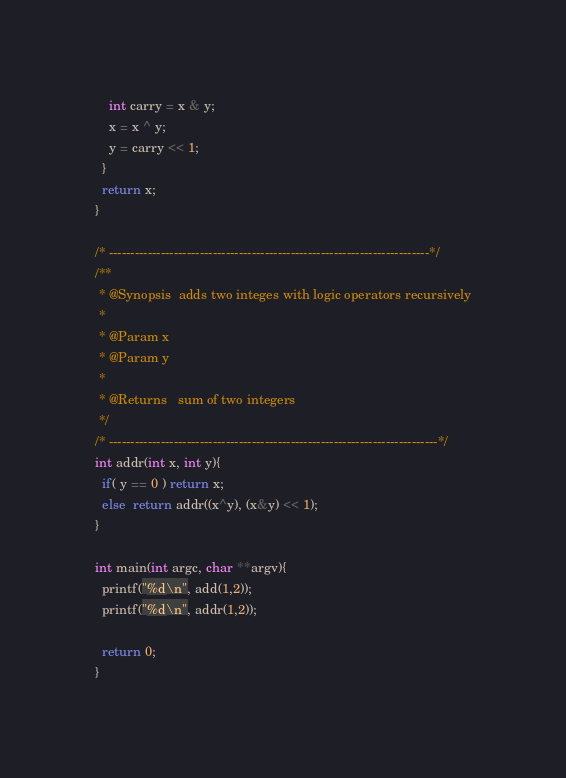<code> <loc_0><loc_0><loc_500><loc_500><_C_>    int carry = x & y;
    x = x ^ y;
    y = carry << 1;
  }
  return x;
}

/* --------------------------------------------------------------------------*/
/**
 * @Synopsis  adds two integes with logic operators recursively
 *
 * @Param x
 * @Param y
 *
 * @Returns   sum of two integers
 */
/* ----------------------------------------------------------------------------*/
int addr(int x, int y){
  if( y == 0 ) return x;
  else  return addr((x^y), (x&y) << 1);
}

int main(int argc, char **argv){
  printf("%d\n", add(1,2));
  printf("%d\n", addr(1,2));

  return 0;
}

</code> 